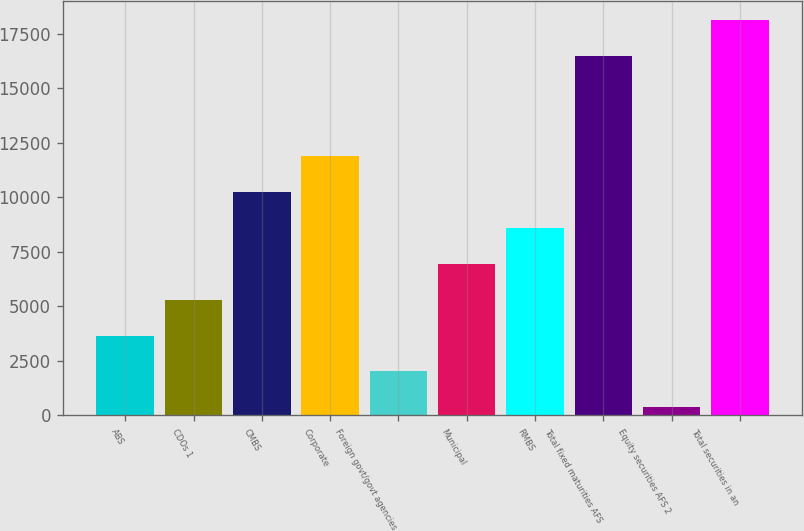<chart> <loc_0><loc_0><loc_500><loc_500><bar_chart><fcel>ABS<fcel>CDOs 1<fcel>CMBS<fcel>Corporate<fcel>Foreign govt/govt agencies<fcel>Municipal<fcel>RMBS<fcel>Total fixed maturities AFS<fcel>Equity securities AFS 2<fcel>Total securities in an<nl><fcel>3662.2<fcel>5309.3<fcel>10250.6<fcel>11897.7<fcel>2015.1<fcel>6956.4<fcel>8603.5<fcel>16471<fcel>368<fcel>18118.1<nl></chart> 